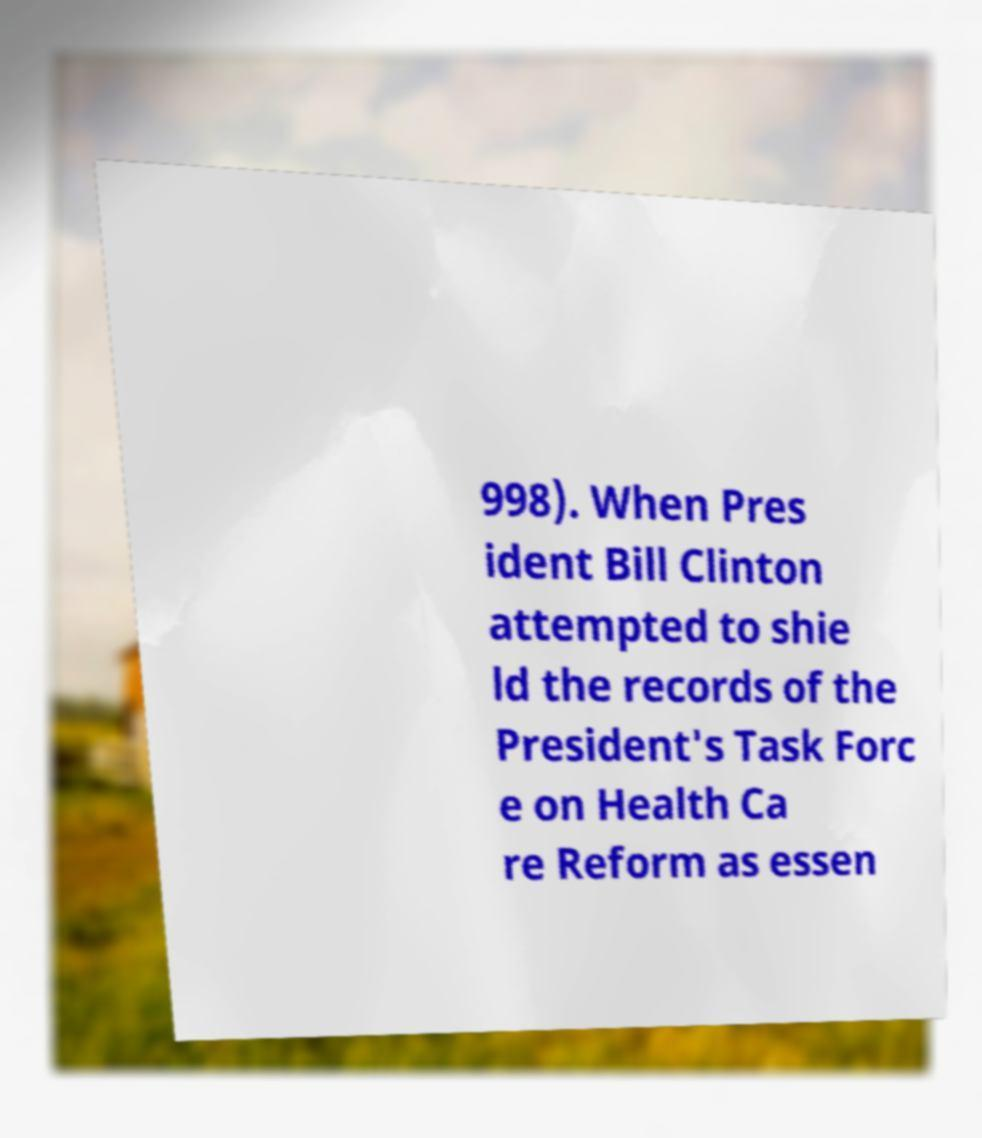Please identify and transcribe the text found in this image. 998). When Pres ident Bill Clinton attempted to shie ld the records of the President's Task Forc e on Health Ca re Reform as essen 